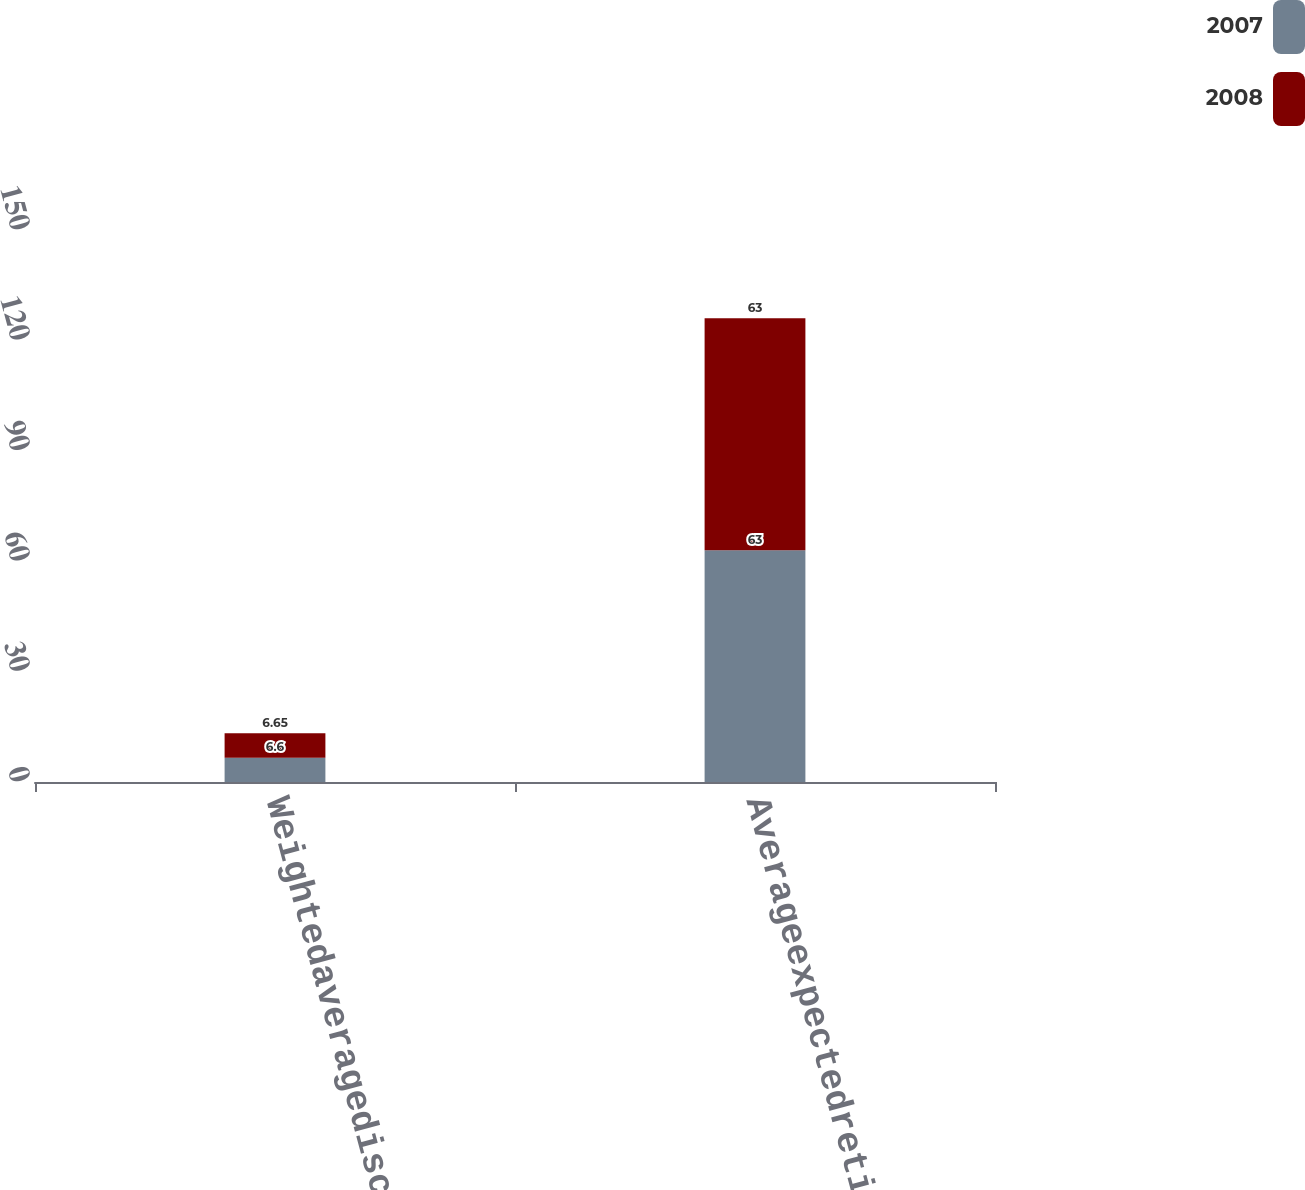Convert chart. <chart><loc_0><loc_0><loc_500><loc_500><stacked_bar_chart><ecel><fcel>Weightedaveragediscountrate<fcel>Averageexpectedretirementage<nl><fcel>2007<fcel>6.6<fcel>63<nl><fcel>2008<fcel>6.65<fcel>63<nl></chart> 